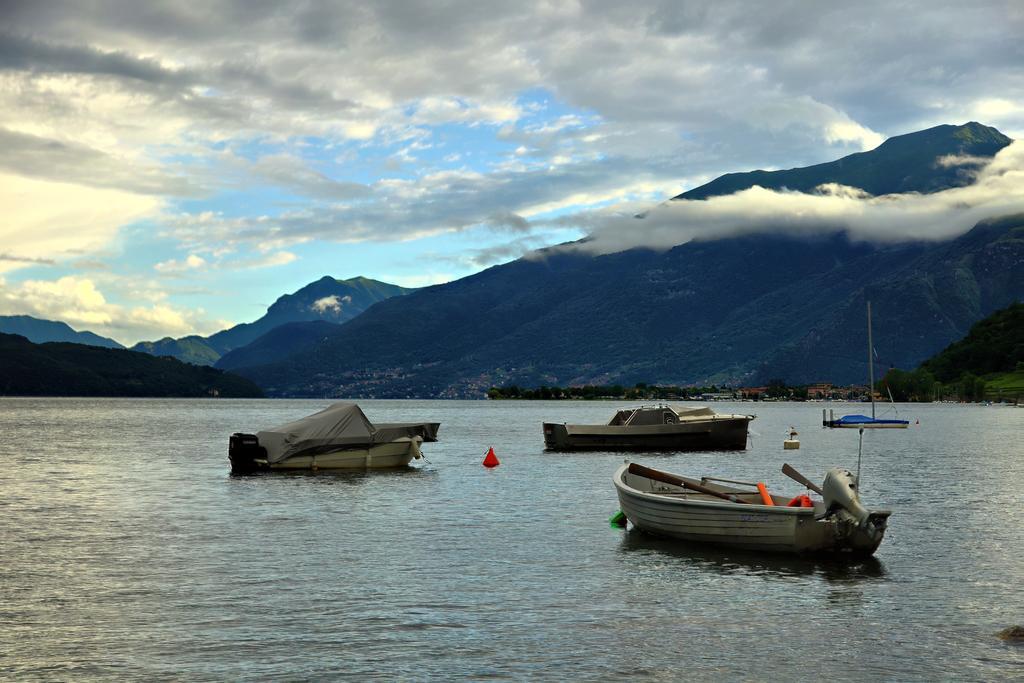How would you summarize this image in a sentence or two? In this image I can see few mountains, trees and few boats on the water surface. The sky is in blue and white color. 